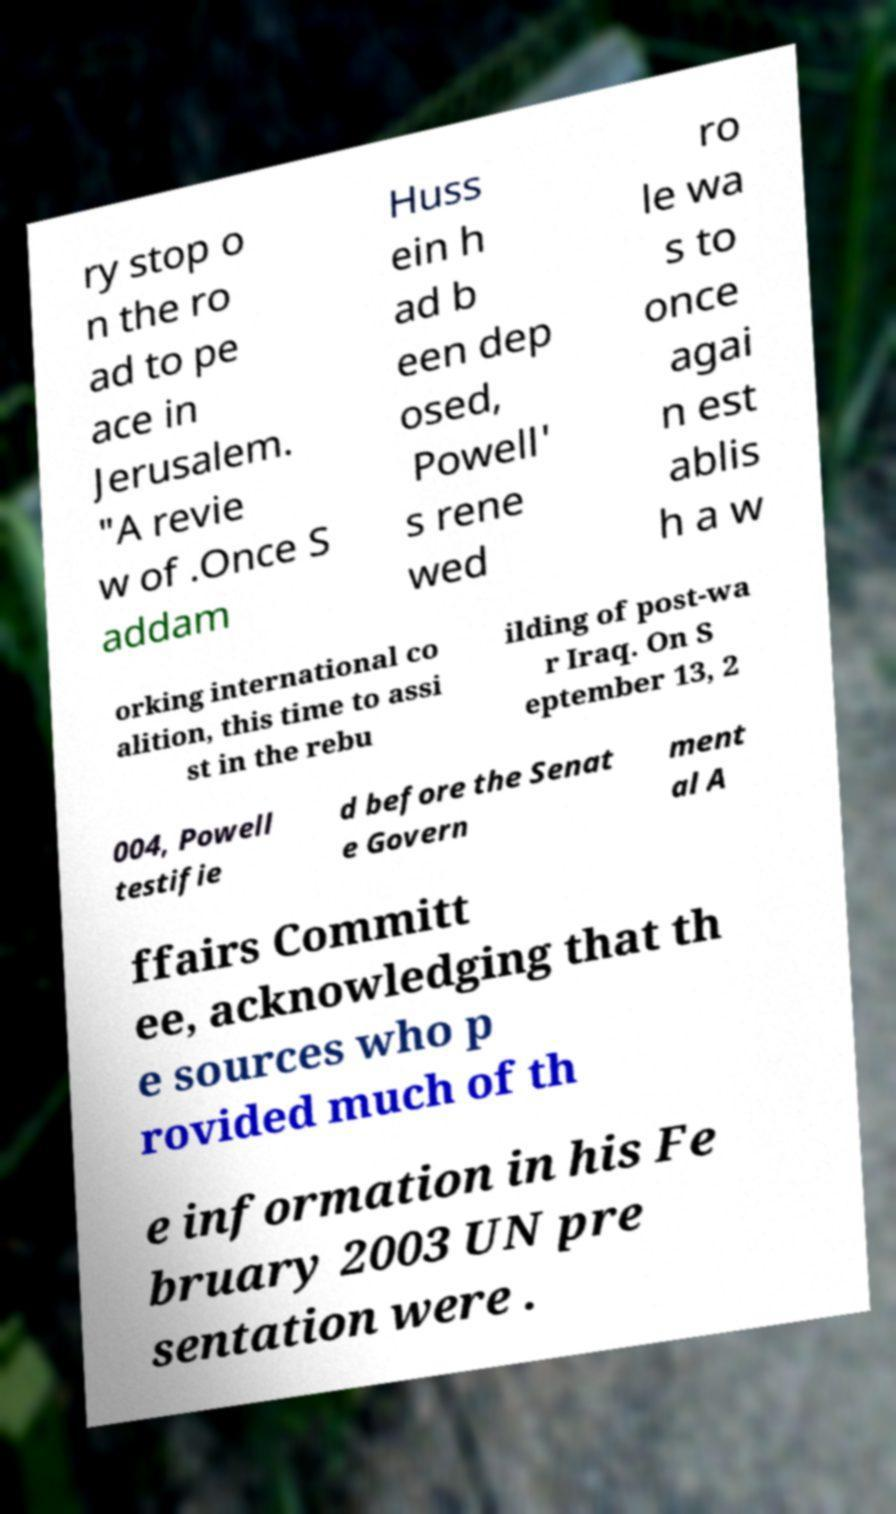Can you read and provide the text displayed in the image?This photo seems to have some interesting text. Can you extract and type it out for me? ry stop o n the ro ad to pe ace in Jerusalem. "A revie w of .Once S addam Huss ein h ad b een dep osed, Powell' s rene wed ro le wa s to once agai n est ablis h a w orking international co alition, this time to assi st in the rebu ilding of post-wa r Iraq. On S eptember 13, 2 004, Powell testifie d before the Senat e Govern ment al A ffairs Committ ee, acknowledging that th e sources who p rovided much of th e information in his Fe bruary 2003 UN pre sentation were . 